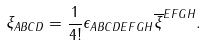Convert formula to latex. <formula><loc_0><loc_0><loc_500><loc_500>\xi _ { A B C D } = \frac { 1 } { 4 ! } \epsilon _ { A B C D E F G H } \overline { \xi } ^ { E F G H } .</formula> 